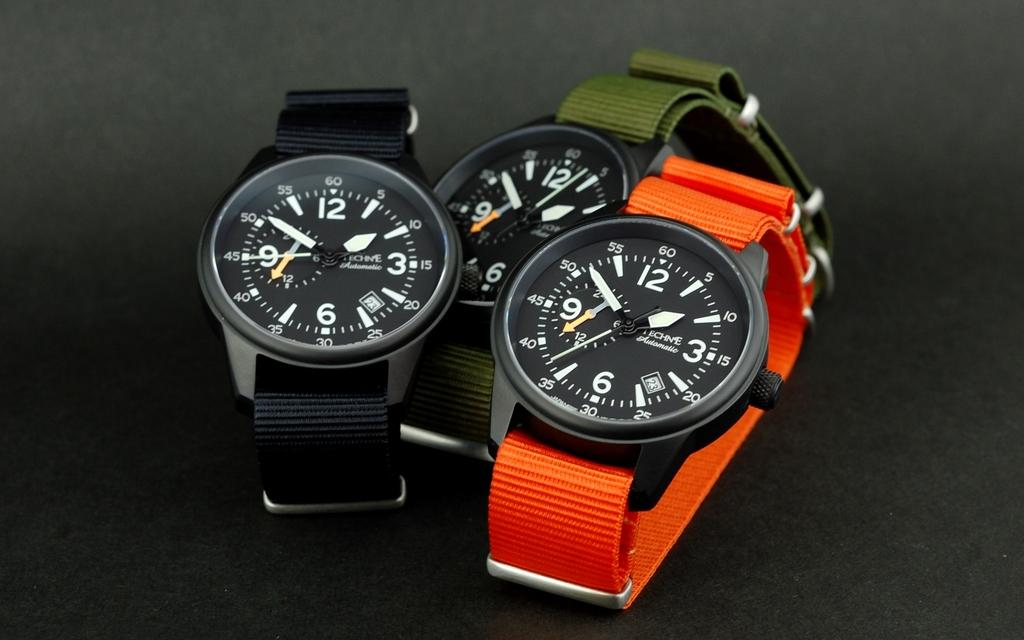Provide a one-sentence caption for the provided image. A watch with a green fabric band showing the current time as 1:52. 